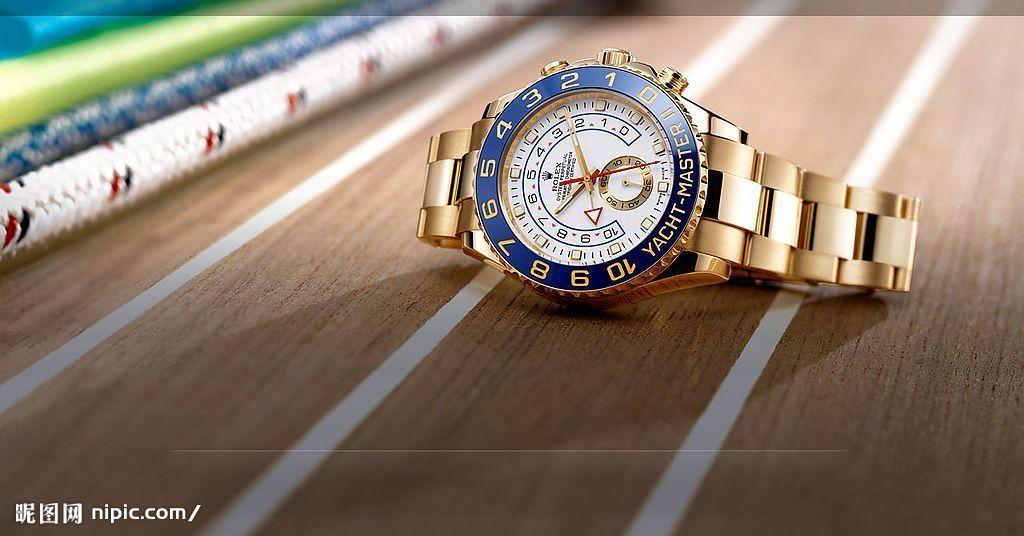<image>
Give a short and clear explanation of the subsequent image. A blue and gold Rolex watch with Yacht Master II on it. 